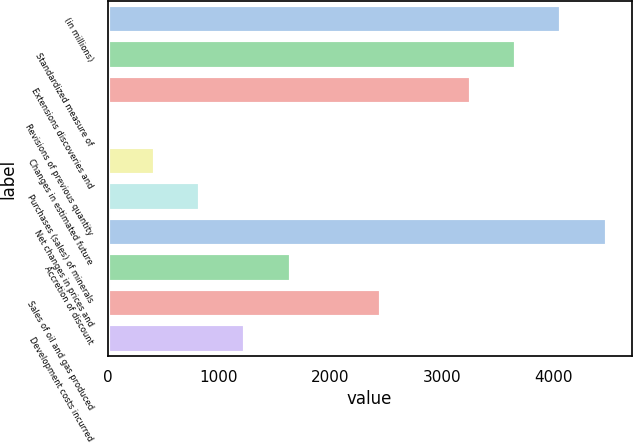Convert chart. <chart><loc_0><loc_0><loc_500><loc_500><bar_chart><fcel>(in millions)<fcel>Standardized measure of<fcel>Extensions discoveries and<fcel>Revisions of previous quantity<fcel>Changes in estimated future<fcel>Purchases (sales) of minerals<fcel>Net changes in prices and<fcel>Accretion of discount<fcel>Sales of oil and gas produced<fcel>Development costs incurred<nl><fcel>4074<fcel>3668.6<fcel>3263.2<fcel>20<fcel>425.4<fcel>830.8<fcel>4479.4<fcel>1641.6<fcel>2452.4<fcel>1236.2<nl></chart> 